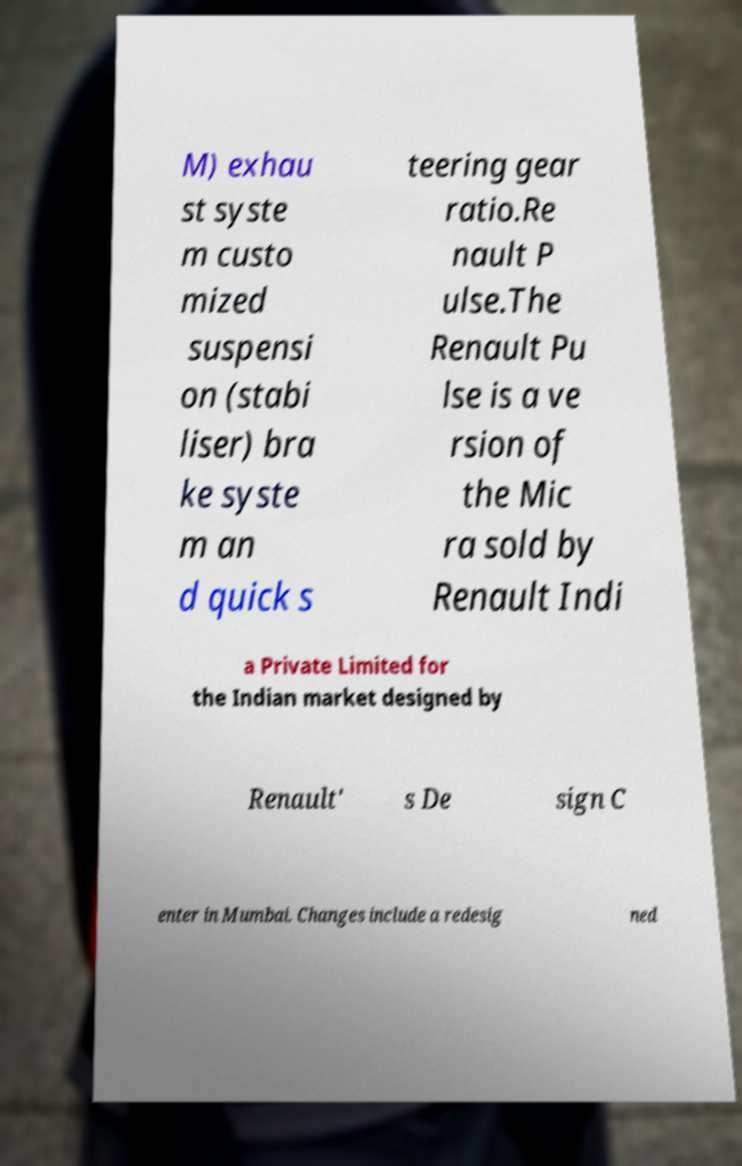I need the written content from this picture converted into text. Can you do that? M) exhau st syste m custo mized suspensi on (stabi liser) bra ke syste m an d quick s teering gear ratio.Re nault P ulse.The Renault Pu lse is a ve rsion of the Mic ra sold by Renault Indi a Private Limited for the Indian market designed by Renault' s De sign C enter in Mumbai. Changes include a redesig ned 